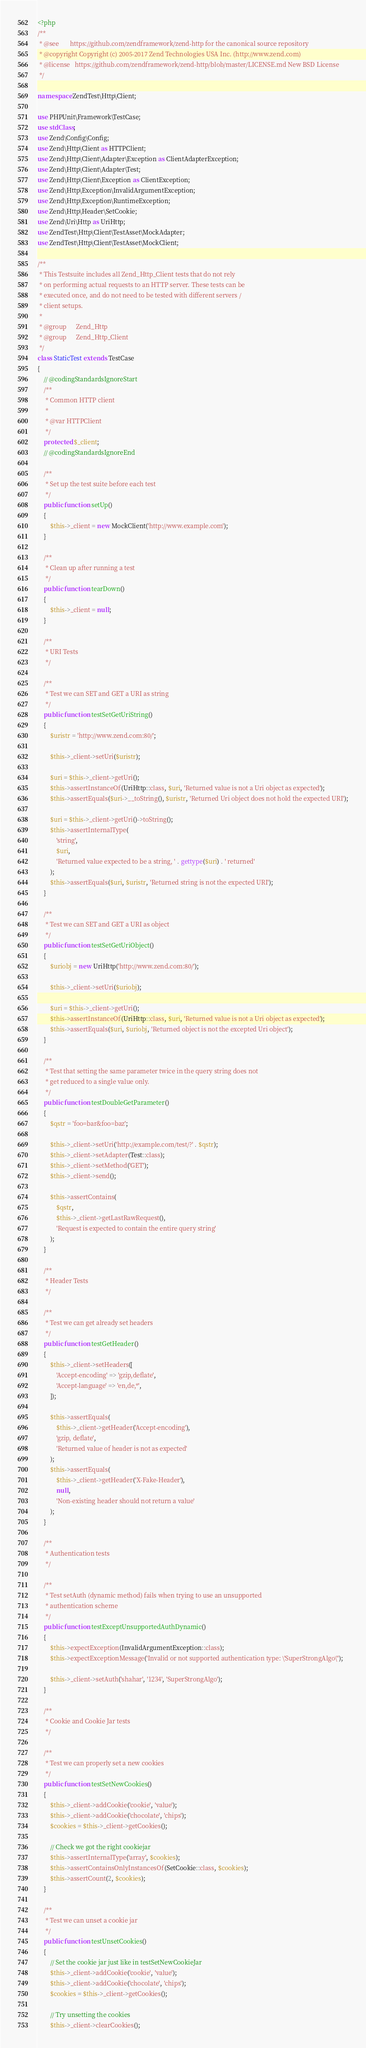<code> <loc_0><loc_0><loc_500><loc_500><_PHP_><?php
/**
 * @see       https://github.com/zendframework/zend-http for the canonical source repository
 * @copyright Copyright (c) 2005-2017 Zend Technologies USA Inc. (http://www.zend.com)
 * @license   https://github.com/zendframework/zend-http/blob/master/LICENSE.md New BSD License
 */

namespace ZendTest\Http\Client;

use PHPUnit\Framework\TestCase;
use stdClass;
use Zend\Config\Config;
use Zend\Http\Client as HTTPClient;
use Zend\Http\Client\Adapter\Exception as ClientAdapterException;
use Zend\Http\Client\Adapter\Test;
use Zend\Http\Client\Exception as ClientException;
use Zend\Http\Exception\InvalidArgumentException;
use Zend\Http\Exception\RuntimeException;
use Zend\Http\Header\SetCookie;
use Zend\Uri\Http as UriHttp;
use ZendTest\Http\Client\TestAsset\MockAdapter;
use ZendTest\Http\Client\TestAsset\MockClient;

/**
 * This Testsuite includes all Zend_Http_Client tests that do not rely
 * on performing actual requests to an HTTP server. These tests can be
 * executed once, and do not need to be tested with different servers /
 * client setups.
 *
 * @group      Zend_Http
 * @group      Zend_Http_Client
 */
class StaticTest extends TestCase
{
    // @codingStandardsIgnoreStart
    /**
     * Common HTTP client
     *
     * @var HTTPClient
     */
    protected $_client;
    // @codingStandardsIgnoreEnd

    /**
     * Set up the test suite before each test
     */
    public function setUp()
    {
        $this->_client = new MockClient('http://www.example.com');
    }

    /**
     * Clean up after running a test
     */
    public function tearDown()
    {
        $this->_client = null;
    }

    /**
     * URI Tests
     */

    /**
     * Test we can SET and GET a URI as string
     */
    public function testSetGetUriString()
    {
        $uristr = 'http://www.zend.com:80/';

        $this->_client->setUri($uristr);

        $uri = $this->_client->getUri();
        $this->assertInstanceOf(UriHttp::class, $uri, 'Returned value is not a Uri object as expected');
        $this->assertEquals($uri->__toString(), $uristr, 'Returned Uri object does not hold the expected URI');

        $uri = $this->_client->getUri()->toString();
        $this->assertInternalType(
            'string',
            $uri,
            'Returned value expected to be a string, ' . gettype($uri) . ' returned'
        );
        $this->assertEquals($uri, $uristr, 'Returned string is not the expected URI');
    }

    /**
     * Test we can SET and GET a URI as object
     */
    public function testSetGetUriObject()
    {
        $uriobj = new UriHttp('http://www.zend.com:80/');

        $this->_client->setUri($uriobj);

        $uri = $this->_client->getUri();
        $this->assertInstanceOf(UriHttp::class, $uri, 'Returned value is not a Uri object as expected');
        $this->assertEquals($uri, $uriobj, 'Returned object is not the excepted Uri object');
    }

    /**
     * Test that setting the same parameter twice in the query string does not
     * get reduced to a single value only.
     */
    public function testDoubleGetParameter()
    {
        $qstr = 'foo=bar&foo=baz';

        $this->_client->setUri('http://example.com/test/?' . $qstr);
        $this->_client->setAdapter(Test::class);
        $this->_client->setMethod('GET');
        $this->_client->send();

        $this->assertContains(
            $qstr,
            $this->_client->getLastRawRequest(),
            'Request is expected to contain the entire query string'
        );
    }

    /**
     * Header Tests
     */

    /**
     * Test we can get already set headers
     */
    public function testGetHeader()
    {
        $this->_client->setHeaders([
            'Accept-encoding' => 'gzip,deflate',
            'Accept-language' => 'en,de,*',
        ]);

        $this->assertEquals(
            $this->_client->getHeader('Accept-encoding'),
            'gzip, deflate',
            'Returned value of header is not as expected'
        );
        $this->assertEquals(
            $this->_client->getHeader('X-Fake-Header'),
            null,
            'Non-existing header should not return a value'
        );
    }

    /**
     * Authentication tests
     */

    /**
     * Test setAuth (dynamic method) fails when trying to use an unsupported
     * authentication scheme
     */
    public function testExceptUnsupportedAuthDynamic()
    {
        $this->expectException(InvalidArgumentException::class);
        $this->expectExceptionMessage('Invalid or not supported authentication type: \'SuperStrongAlgo\'');

        $this->_client->setAuth('shahar', '1234', 'SuperStrongAlgo');
    }

    /**
     * Cookie and Cookie Jar tests
     */

    /**
     * Test we can properly set a new cookies
     */
    public function testSetNewCookies()
    {
        $this->_client->addCookie('cookie', 'value');
        $this->_client->addCookie('chocolate', 'chips');
        $cookies = $this->_client->getCookies();

        // Check we got the right cookiejar
        $this->assertInternalType('array', $cookies);
        $this->assertContainsOnlyInstancesOf(SetCookie::class, $cookies);
        $this->assertCount(2, $cookies);
    }

    /**
     * Test we can unset a cookie jar
     */
    public function testUnsetCookies()
    {
        // Set the cookie jar just like in testSetNewCookieJar
        $this->_client->addCookie('cookie', 'value');
        $this->_client->addCookie('chocolate', 'chips');
        $cookies = $this->_client->getCookies();

        // Try unsetting the cookies
        $this->_client->clearCookies();</code> 